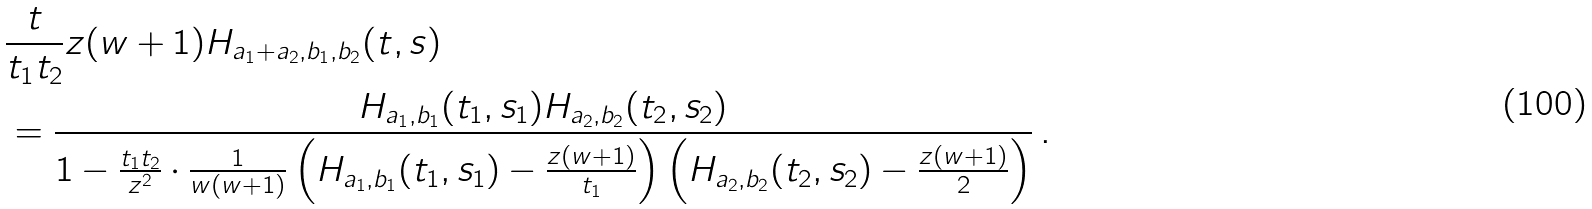Convert formula to latex. <formula><loc_0><loc_0><loc_500><loc_500>& \frac { t } { t _ { 1 } t _ { 2 } } z ( w + 1 ) H _ { a _ { 1 } + a _ { 2 } , b _ { 1 } , b _ { 2 } } ( t , s ) \\ & = \frac { H _ { a _ { 1 } , b _ { 1 } } ( t _ { 1 } , s _ { 1 } ) H _ { a _ { 2 } , b _ { 2 } } ( t _ { 2 } , s _ { 2 } ) } { 1 - \frac { t _ { 1 } t _ { 2 } } { z ^ { 2 } } \cdot \frac { 1 } { w ( w + 1 ) } \left ( H _ { a _ { 1 } , b _ { 1 } } ( t _ { 1 } , s _ { 1 } ) - \frac { z ( w + 1 ) } { t _ { 1 } } \right ) \left ( H _ { a _ { 2 } , b _ { 2 } } ( t _ { 2 } , s _ { 2 } ) - \frac { z ( w + 1 ) } { 2 } \right ) } \, .</formula> 